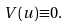Convert formula to latex. <formula><loc_0><loc_0><loc_500><loc_500>V ( u ) { \equiv } 0 .</formula> 